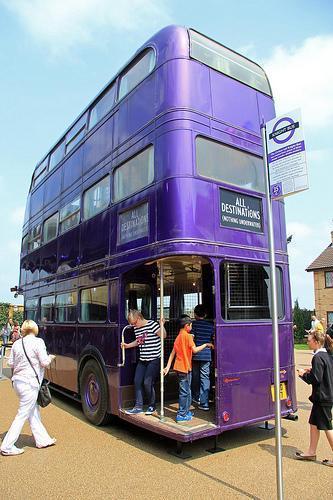How many boys are on the bus?
Give a very brief answer. 2. How many girls are on the bus?
Give a very brief answer. 1. 